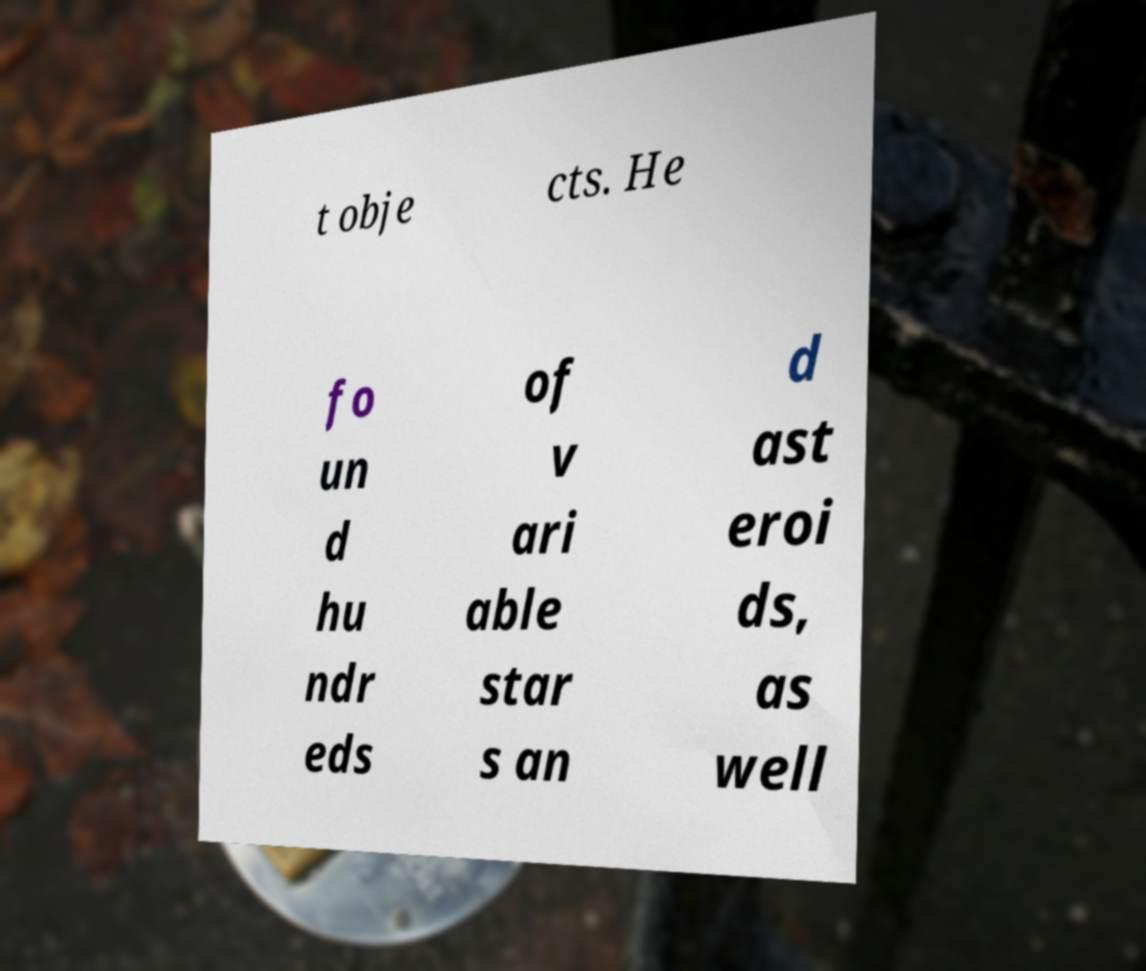For documentation purposes, I need the text within this image transcribed. Could you provide that? t obje cts. He fo un d hu ndr eds of v ari able star s an d ast eroi ds, as well 